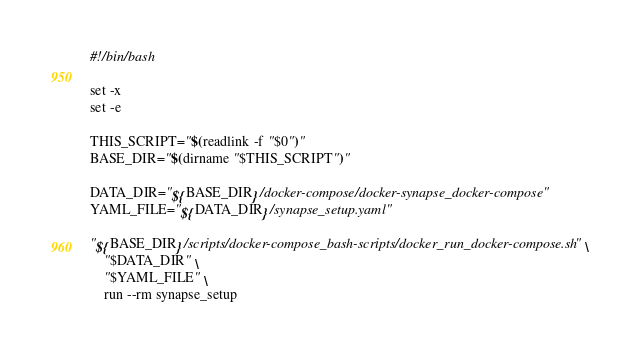<code> <loc_0><loc_0><loc_500><loc_500><_Bash_>#!/bin/bash

set -x
set -e

THIS_SCRIPT="$(readlink -f "$0")"
BASE_DIR="$(dirname "$THIS_SCRIPT")"

DATA_DIR="${BASE_DIR}/docker-compose/docker-synapse_docker-compose"
YAML_FILE="${DATA_DIR}/synapse_setup.yaml"

"${BASE_DIR}/scripts/docker-compose_bash-scripts/docker_run_docker-compose.sh" \
	"$DATA_DIR" \
	"$YAML_FILE" \
	run --rm synapse_setup

</code> 